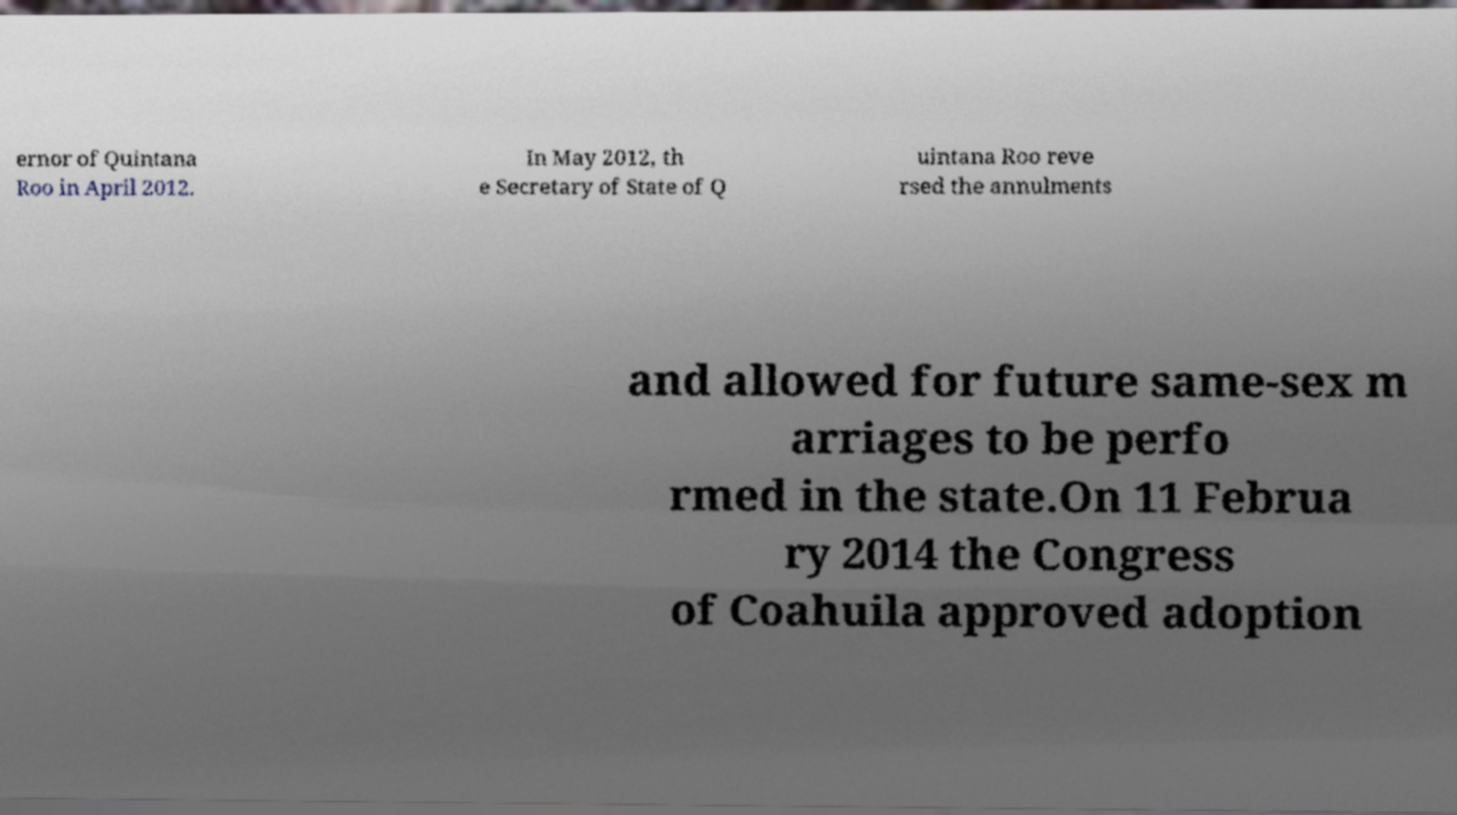For documentation purposes, I need the text within this image transcribed. Could you provide that? ernor of Quintana Roo in April 2012. In May 2012, th e Secretary of State of Q uintana Roo reve rsed the annulments and allowed for future same-sex m arriages to be perfo rmed in the state.On 11 Februa ry 2014 the Congress of Coahuila approved adoption 